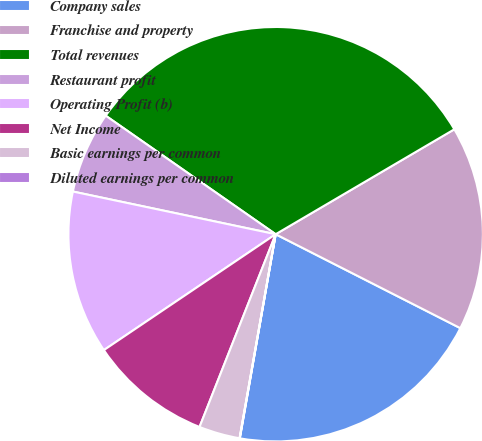<chart> <loc_0><loc_0><loc_500><loc_500><pie_chart><fcel>Company sales<fcel>Franchise and property<fcel>Total revenues<fcel>Restaurant profit<fcel>Operating Profit (b)<fcel>Net Income<fcel>Basic earnings per common<fcel>Diluted earnings per common<nl><fcel>20.28%<fcel>15.94%<fcel>31.86%<fcel>6.39%<fcel>12.75%<fcel>9.57%<fcel>3.2%<fcel>0.02%<nl></chart> 